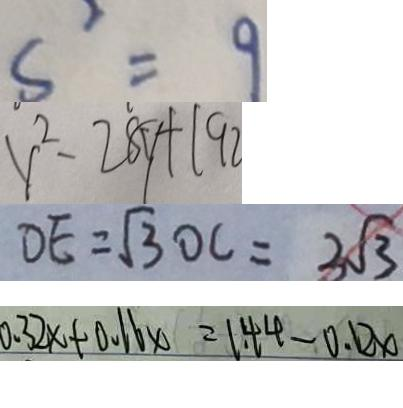<formula> <loc_0><loc_0><loc_500><loc_500>s ^ { 2 } = 9 
 y ^ { 2 } - 2 8 y + 1 9 2 
 D E = \sqrt { 3 } O C = 3 \sqrt { 3 } 
 0 . 3 2 x + 0 . 1 6 x = 1 . 4 4 - 0 . 1 2 x</formula> 